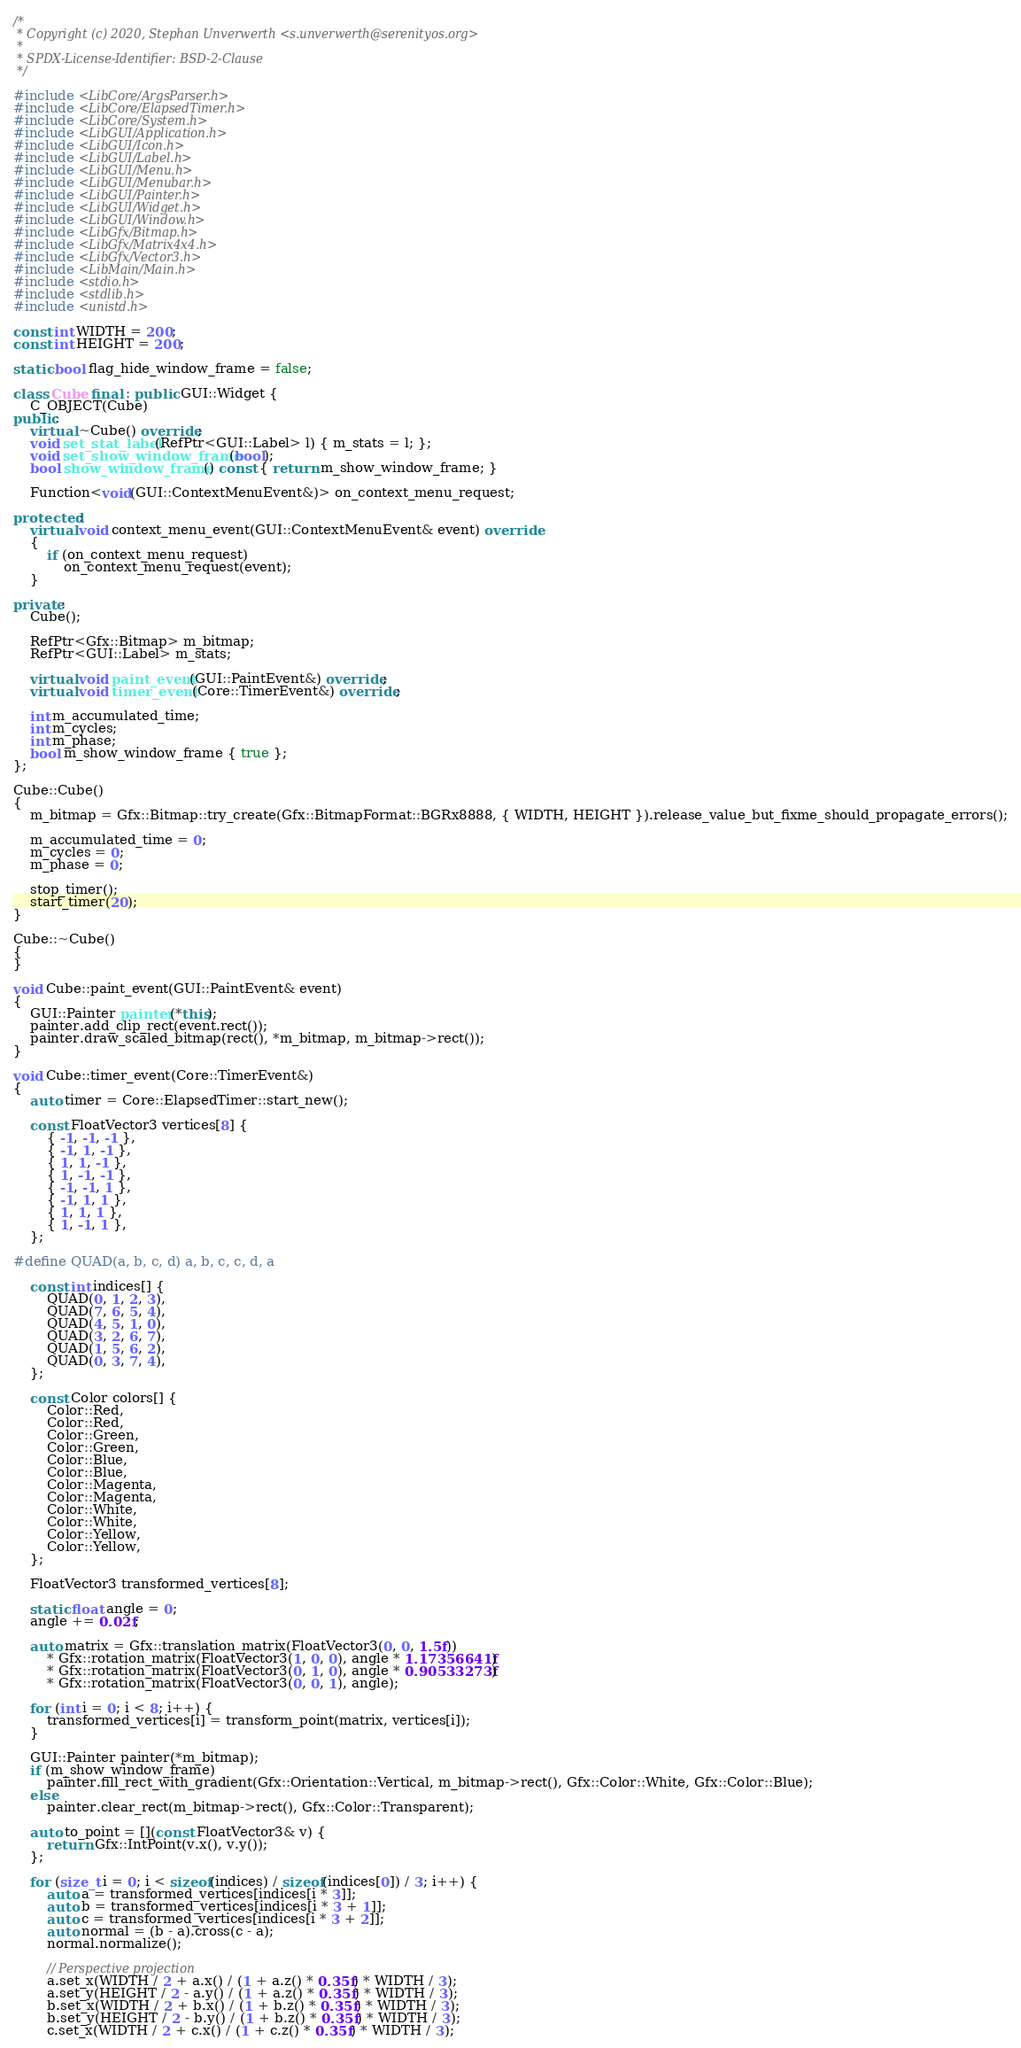Convert code to text. <code><loc_0><loc_0><loc_500><loc_500><_C++_>/*
 * Copyright (c) 2020, Stephan Unverwerth <s.unverwerth@serenityos.org>
 *
 * SPDX-License-Identifier: BSD-2-Clause
 */

#include <LibCore/ArgsParser.h>
#include <LibCore/ElapsedTimer.h>
#include <LibCore/System.h>
#include <LibGUI/Application.h>
#include <LibGUI/Icon.h>
#include <LibGUI/Label.h>
#include <LibGUI/Menu.h>
#include <LibGUI/Menubar.h>
#include <LibGUI/Painter.h>
#include <LibGUI/Widget.h>
#include <LibGUI/Window.h>
#include <LibGfx/Bitmap.h>
#include <LibGfx/Matrix4x4.h>
#include <LibGfx/Vector3.h>
#include <LibMain/Main.h>
#include <stdio.h>
#include <stdlib.h>
#include <unistd.h>

const int WIDTH = 200;
const int HEIGHT = 200;

static bool flag_hide_window_frame = false;

class Cube final : public GUI::Widget {
    C_OBJECT(Cube)
public:
    virtual ~Cube() override;
    void set_stat_label(RefPtr<GUI::Label> l) { m_stats = l; };
    void set_show_window_frame(bool);
    bool show_window_frame() const { return m_show_window_frame; }

    Function<void(GUI::ContextMenuEvent&)> on_context_menu_request;

protected:
    virtual void context_menu_event(GUI::ContextMenuEvent& event) override
    {
        if (on_context_menu_request)
            on_context_menu_request(event);
    }

private:
    Cube();

    RefPtr<Gfx::Bitmap> m_bitmap;
    RefPtr<GUI::Label> m_stats;

    virtual void paint_event(GUI::PaintEvent&) override;
    virtual void timer_event(Core::TimerEvent&) override;

    int m_accumulated_time;
    int m_cycles;
    int m_phase;
    bool m_show_window_frame { true };
};

Cube::Cube()
{
    m_bitmap = Gfx::Bitmap::try_create(Gfx::BitmapFormat::BGRx8888, { WIDTH, HEIGHT }).release_value_but_fixme_should_propagate_errors();

    m_accumulated_time = 0;
    m_cycles = 0;
    m_phase = 0;

    stop_timer();
    start_timer(20);
}

Cube::~Cube()
{
}

void Cube::paint_event(GUI::PaintEvent& event)
{
    GUI::Painter painter(*this);
    painter.add_clip_rect(event.rect());
    painter.draw_scaled_bitmap(rect(), *m_bitmap, m_bitmap->rect());
}

void Cube::timer_event(Core::TimerEvent&)
{
    auto timer = Core::ElapsedTimer::start_new();

    const FloatVector3 vertices[8] {
        { -1, -1, -1 },
        { -1, 1, -1 },
        { 1, 1, -1 },
        { 1, -1, -1 },
        { -1, -1, 1 },
        { -1, 1, 1 },
        { 1, 1, 1 },
        { 1, -1, 1 },
    };

#define QUAD(a, b, c, d) a, b, c, c, d, a

    const int indices[] {
        QUAD(0, 1, 2, 3),
        QUAD(7, 6, 5, 4),
        QUAD(4, 5, 1, 0),
        QUAD(3, 2, 6, 7),
        QUAD(1, 5, 6, 2),
        QUAD(0, 3, 7, 4),
    };

    const Color colors[] {
        Color::Red,
        Color::Red,
        Color::Green,
        Color::Green,
        Color::Blue,
        Color::Blue,
        Color::Magenta,
        Color::Magenta,
        Color::White,
        Color::White,
        Color::Yellow,
        Color::Yellow,
    };

    FloatVector3 transformed_vertices[8];

    static float angle = 0;
    angle += 0.02f;

    auto matrix = Gfx::translation_matrix(FloatVector3(0, 0, 1.5f))
        * Gfx::rotation_matrix(FloatVector3(1, 0, 0), angle * 1.17356641f)
        * Gfx::rotation_matrix(FloatVector3(0, 1, 0), angle * 0.90533273f)
        * Gfx::rotation_matrix(FloatVector3(0, 0, 1), angle);

    for (int i = 0; i < 8; i++) {
        transformed_vertices[i] = transform_point(matrix, vertices[i]);
    }

    GUI::Painter painter(*m_bitmap);
    if (m_show_window_frame)
        painter.fill_rect_with_gradient(Gfx::Orientation::Vertical, m_bitmap->rect(), Gfx::Color::White, Gfx::Color::Blue);
    else
        painter.clear_rect(m_bitmap->rect(), Gfx::Color::Transparent);

    auto to_point = [](const FloatVector3& v) {
        return Gfx::IntPoint(v.x(), v.y());
    };

    for (size_t i = 0; i < sizeof(indices) / sizeof(indices[0]) / 3; i++) {
        auto a = transformed_vertices[indices[i * 3]];
        auto b = transformed_vertices[indices[i * 3 + 1]];
        auto c = transformed_vertices[indices[i * 3 + 2]];
        auto normal = (b - a).cross(c - a);
        normal.normalize();

        // Perspective projection
        a.set_x(WIDTH / 2 + a.x() / (1 + a.z() * 0.35f) * WIDTH / 3);
        a.set_y(HEIGHT / 2 - a.y() / (1 + a.z() * 0.35f) * WIDTH / 3);
        b.set_x(WIDTH / 2 + b.x() / (1 + b.z() * 0.35f) * WIDTH / 3);
        b.set_y(HEIGHT / 2 - b.y() / (1 + b.z() * 0.35f) * WIDTH / 3);
        c.set_x(WIDTH / 2 + c.x() / (1 + c.z() * 0.35f) * WIDTH / 3);</code> 